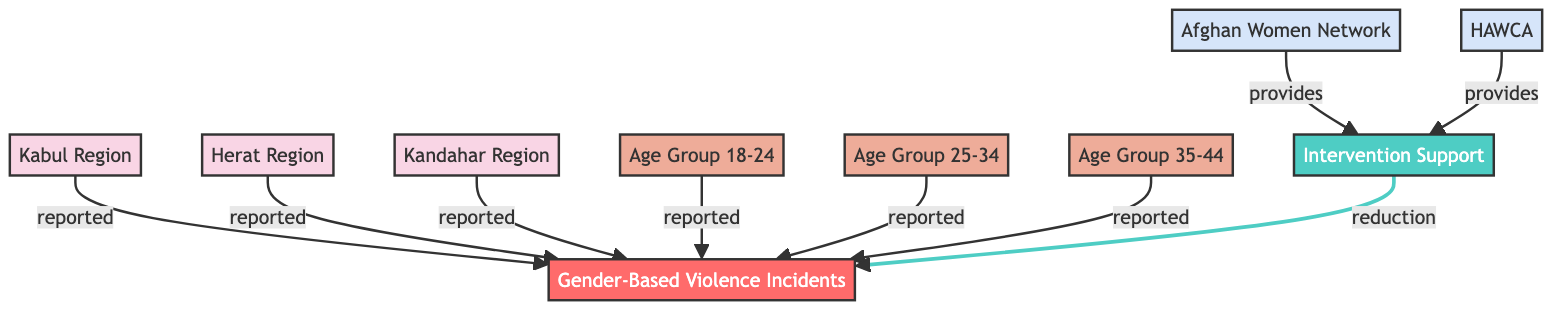What are the regions represented in the diagram? The diagram includes three distinct regions: Kabul, Herat, and Kandahar. These are identified as nodes connected to the primary node representing Gender-Based Violence Incidents.
Answer: Kabul, Herat, Kandahar How many age groups are represented in the diagram? There are three specific age groups represented in the diagram: Age Group 18-24, Age Group 25-34, and Age Group 35-44. Each of these age groups is connected separately to the Gender-Based Violence Incidents node.
Answer: Three Which local organization provides intervention support? The local organizations that provide intervention support are the Afghan Women Network and HAWCA. These organizations are depicted as nodes connecting to the Intervention Support node.
Answer: Afghan Women Network, HAWCA What kind of relationship exists between "Intervention Support" and "Gender-Based Violence Incidents"? The relationship between "Intervention Support" and "Gender-Based Violence Incidents" is a reduction type, indicating that intervention efforts aim to decrease reported incidents of gender-based violence. This is shown through a direct edge labeled "reduction."
Answer: Reduction How many total edges are present in this directed graph? The total number of edges can be counted by observing the connections between nodes. There are nine edges in total connecting the nodes: three from regions, three from age groups, two from local organizations to intervention support, and one from intervention support to gender-based violence incidents.
Answer: Nine Which age group is not represented by any intervention support? The diagram does not mention any specific intervention support targeted at a particular age group directly. Each age group connects to Gender-Based Violence Incidents without specifying an intervention. Thus, none of these age groups are singled out for direct support.
Answer: None What does the edge type "reported" signify in this diagram? The "reported" edge type signifies the relationship where certain regions and age groups are sources of reported incidents of gender-based violence. Each region and age group connects to the GBV incidents node with this relationship type, indicating their role in reporting.
Answer: Reported Which local organization is not mentioned in the graph? The graph only mentions two local organizations, Afghan Women Network and HAWCA. Any organization not specifically named in the diagram is not included as a local intervention provider.
Answer: None 